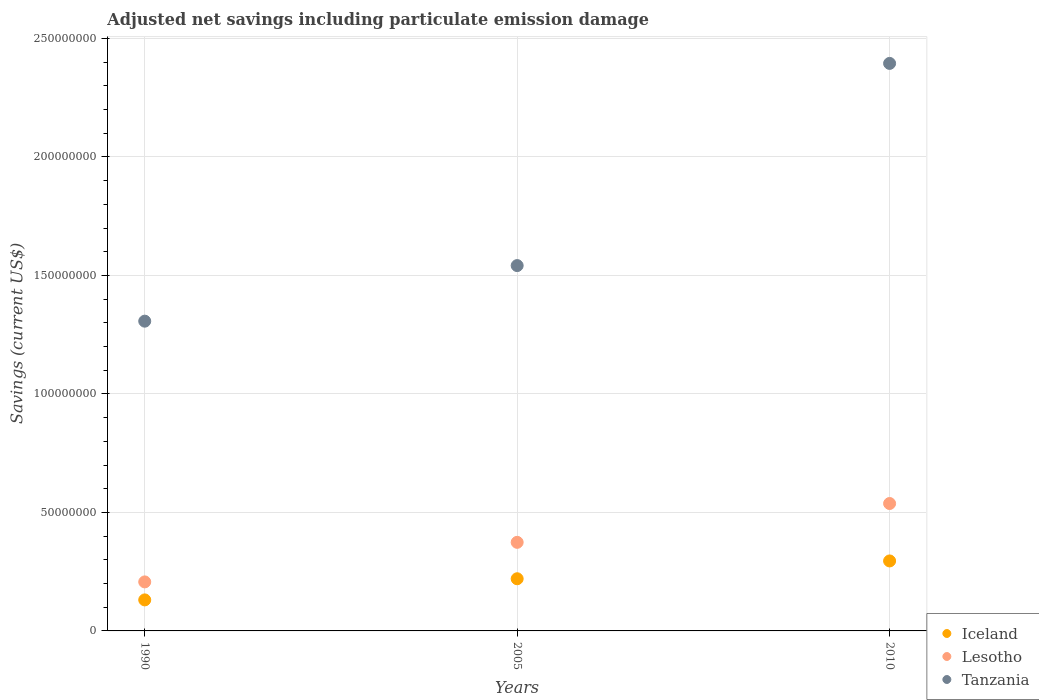How many different coloured dotlines are there?
Give a very brief answer. 3. What is the net savings in Tanzania in 1990?
Make the answer very short. 1.31e+08. Across all years, what is the maximum net savings in Tanzania?
Offer a terse response. 2.39e+08. Across all years, what is the minimum net savings in Lesotho?
Ensure brevity in your answer.  2.07e+07. In which year was the net savings in Lesotho maximum?
Ensure brevity in your answer.  2010. What is the total net savings in Tanzania in the graph?
Give a very brief answer. 5.24e+08. What is the difference between the net savings in Iceland in 1990 and that in 2010?
Your response must be concise. -1.64e+07. What is the difference between the net savings in Iceland in 2005 and the net savings in Tanzania in 2010?
Ensure brevity in your answer.  -2.17e+08. What is the average net savings in Tanzania per year?
Give a very brief answer. 1.75e+08. In the year 2010, what is the difference between the net savings in Lesotho and net savings in Iceland?
Keep it short and to the point. 2.42e+07. What is the ratio of the net savings in Lesotho in 1990 to that in 2010?
Your answer should be very brief. 0.38. Is the difference between the net savings in Lesotho in 1990 and 2010 greater than the difference between the net savings in Iceland in 1990 and 2010?
Your answer should be very brief. No. What is the difference between the highest and the second highest net savings in Tanzania?
Your answer should be compact. 8.53e+07. What is the difference between the highest and the lowest net savings in Tanzania?
Ensure brevity in your answer.  1.09e+08. In how many years, is the net savings in Tanzania greater than the average net savings in Tanzania taken over all years?
Make the answer very short. 1. Is it the case that in every year, the sum of the net savings in Lesotho and net savings in Iceland  is greater than the net savings in Tanzania?
Provide a succinct answer. No. How many years are there in the graph?
Provide a short and direct response. 3. What is the difference between two consecutive major ticks on the Y-axis?
Your answer should be very brief. 5.00e+07. Are the values on the major ticks of Y-axis written in scientific E-notation?
Your answer should be compact. No. How many legend labels are there?
Give a very brief answer. 3. How are the legend labels stacked?
Make the answer very short. Vertical. What is the title of the graph?
Provide a succinct answer. Adjusted net savings including particulate emission damage. Does "Papua New Guinea" appear as one of the legend labels in the graph?
Your answer should be very brief. No. What is the label or title of the Y-axis?
Provide a succinct answer. Savings (current US$). What is the Savings (current US$) of Iceland in 1990?
Provide a short and direct response. 1.31e+07. What is the Savings (current US$) of Lesotho in 1990?
Offer a very short reply. 2.07e+07. What is the Savings (current US$) in Tanzania in 1990?
Provide a short and direct response. 1.31e+08. What is the Savings (current US$) of Iceland in 2005?
Keep it short and to the point. 2.20e+07. What is the Savings (current US$) of Lesotho in 2005?
Your answer should be very brief. 3.74e+07. What is the Savings (current US$) of Tanzania in 2005?
Give a very brief answer. 1.54e+08. What is the Savings (current US$) in Iceland in 2010?
Your response must be concise. 2.95e+07. What is the Savings (current US$) in Lesotho in 2010?
Offer a terse response. 5.38e+07. What is the Savings (current US$) of Tanzania in 2010?
Your answer should be very brief. 2.39e+08. Across all years, what is the maximum Savings (current US$) in Iceland?
Your response must be concise. 2.95e+07. Across all years, what is the maximum Savings (current US$) in Lesotho?
Make the answer very short. 5.38e+07. Across all years, what is the maximum Savings (current US$) in Tanzania?
Provide a succinct answer. 2.39e+08. Across all years, what is the minimum Savings (current US$) of Iceland?
Offer a very short reply. 1.31e+07. Across all years, what is the minimum Savings (current US$) in Lesotho?
Your response must be concise. 2.07e+07. Across all years, what is the minimum Savings (current US$) of Tanzania?
Offer a terse response. 1.31e+08. What is the total Savings (current US$) in Iceland in the graph?
Provide a succinct answer. 6.46e+07. What is the total Savings (current US$) in Lesotho in the graph?
Make the answer very short. 1.12e+08. What is the total Savings (current US$) of Tanzania in the graph?
Ensure brevity in your answer.  5.24e+08. What is the difference between the Savings (current US$) of Iceland in 1990 and that in 2005?
Provide a short and direct response. -8.93e+06. What is the difference between the Savings (current US$) in Lesotho in 1990 and that in 2005?
Your answer should be very brief. -1.67e+07. What is the difference between the Savings (current US$) of Tanzania in 1990 and that in 2005?
Provide a short and direct response. -2.35e+07. What is the difference between the Savings (current US$) in Iceland in 1990 and that in 2010?
Offer a terse response. -1.64e+07. What is the difference between the Savings (current US$) in Lesotho in 1990 and that in 2010?
Provide a succinct answer. -3.31e+07. What is the difference between the Savings (current US$) of Tanzania in 1990 and that in 2010?
Give a very brief answer. -1.09e+08. What is the difference between the Savings (current US$) in Iceland in 2005 and that in 2010?
Offer a very short reply. -7.52e+06. What is the difference between the Savings (current US$) in Lesotho in 2005 and that in 2010?
Your response must be concise. -1.64e+07. What is the difference between the Savings (current US$) in Tanzania in 2005 and that in 2010?
Give a very brief answer. -8.53e+07. What is the difference between the Savings (current US$) in Iceland in 1990 and the Savings (current US$) in Lesotho in 2005?
Your answer should be compact. -2.43e+07. What is the difference between the Savings (current US$) of Iceland in 1990 and the Savings (current US$) of Tanzania in 2005?
Make the answer very short. -1.41e+08. What is the difference between the Savings (current US$) of Lesotho in 1990 and the Savings (current US$) of Tanzania in 2005?
Provide a succinct answer. -1.33e+08. What is the difference between the Savings (current US$) of Iceland in 1990 and the Savings (current US$) of Lesotho in 2010?
Provide a short and direct response. -4.07e+07. What is the difference between the Savings (current US$) in Iceland in 1990 and the Savings (current US$) in Tanzania in 2010?
Your answer should be very brief. -2.26e+08. What is the difference between the Savings (current US$) in Lesotho in 1990 and the Savings (current US$) in Tanzania in 2010?
Offer a terse response. -2.19e+08. What is the difference between the Savings (current US$) of Iceland in 2005 and the Savings (current US$) of Lesotho in 2010?
Ensure brevity in your answer.  -3.17e+07. What is the difference between the Savings (current US$) of Iceland in 2005 and the Savings (current US$) of Tanzania in 2010?
Provide a succinct answer. -2.17e+08. What is the difference between the Savings (current US$) of Lesotho in 2005 and the Savings (current US$) of Tanzania in 2010?
Your answer should be compact. -2.02e+08. What is the average Savings (current US$) of Iceland per year?
Keep it short and to the point. 2.15e+07. What is the average Savings (current US$) in Lesotho per year?
Provide a short and direct response. 3.73e+07. What is the average Savings (current US$) in Tanzania per year?
Your answer should be very brief. 1.75e+08. In the year 1990, what is the difference between the Savings (current US$) in Iceland and Savings (current US$) in Lesotho?
Offer a terse response. -7.60e+06. In the year 1990, what is the difference between the Savings (current US$) in Iceland and Savings (current US$) in Tanzania?
Offer a terse response. -1.18e+08. In the year 1990, what is the difference between the Savings (current US$) in Lesotho and Savings (current US$) in Tanzania?
Keep it short and to the point. -1.10e+08. In the year 2005, what is the difference between the Savings (current US$) of Iceland and Savings (current US$) of Lesotho?
Ensure brevity in your answer.  -1.54e+07. In the year 2005, what is the difference between the Savings (current US$) in Iceland and Savings (current US$) in Tanzania?
Your response must be concise. -1.32e+08. In the year 2005, what is the difference between the Savings (current US$) in Lesotho and Savings (current US$) in Tanzania?
Provide a succinct answer. -1.17e+08. In the year 2010, what is the difference between the Savings (current US$) in Iceland and Savings (current US$) in Lesotho?
Keep it short and to the point. -2.42e+07. In the year 2010, what is the difference between the Savings (current US$) of Iceland and Savings (current US$) of Tanzania?
Provide a succinct answer. -2.10e+08. In the year 2010, what is the difference between the Savings (current US$) in Lesotho and Savings (current US$) in Tanzania?
Offer a terse response. -1.86e+08. What is the ratio of the Savings (current US$) of Iceland in 1990 to that in 2005?
Make the answer very short. 0.59. What is the ratio of the Savings (current US$) of Lesotho in 1990 to that in 2005?
Ensure brevity in your answer.  0.55. What is the ratio of the Savings (current US$) in Tanzania in 1990 to that in 2005?
Offer a very short reply. 0.85. What is the ratio of the Savings (current US$) of Iceland in 1990 to that in 2010?
Ensure brevity in your answer.  0.44. What is the ratio of the Savings (current US$) in Lesotho in 1990 to that in 2010?
Ensure brevity in your answer.  0.38. What is the ratio of the Savings (current US$) of Tanzania in 1990 to that in 2010?
Keep it short and to the point. 0.55. What is the ratio of the Savings (current US$) in Iceland in 2005 to that in 2010?
Your response must be concise. 0.75. What is the ratio of the Savings (current US$) in Lesotho in 2005 to that in 2010?
Offer a terse response. 0.7. What is the ratio of the Savings (current US$) in Tanzania in 2005 to that in 2010?
Make the answer very short. 0.64. What is the difference between the highest and the second highest Savings (current US$) in Iceland?
Make the answer very short. 7.52e+06. What is the difference between the highest and the second highest Savings (current US$) of Lesotho?
Ensure brevity in your answer.  1.64e+07. What is the difference between the highest and the second highest Savings (current US$) of Tanzania?
Provide a short and direct response. 8.53e+07. What is the difference between the highest and the lowest Savings (current US$) in Iceland?
Provide a succinct answer. 1.64e+07. What is the difference between the highest and the lowest Savings (current US$) of Lesotho?
Offer a very short reply. 3.31e+07. What is the difference between the highest and the lowest Savings (current US$) in Tanzania?
Ensure brevity in your answer.  1.09e+08. 